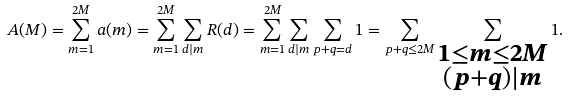Convert formula to latex. <formula><loc_0><loc_0><loc_500><loc_500>A ( M ) = \sum _ { m = 1 } ^ { 2 M } a ( m ) = \sum _ { m = 1 } ^ { 2 M } \sum _ { d | m } R ( d ) = \sum _ { m = 1 } ^ { 2 M } \sum _ { d | m } \sum _ { p + q = d } 1 = \sum _ { p + q \leq 2 M } \sum _ { \substack { 1 \leq m \leq 2 M \\ ( p + q ) | m } } 1 .</formula> 